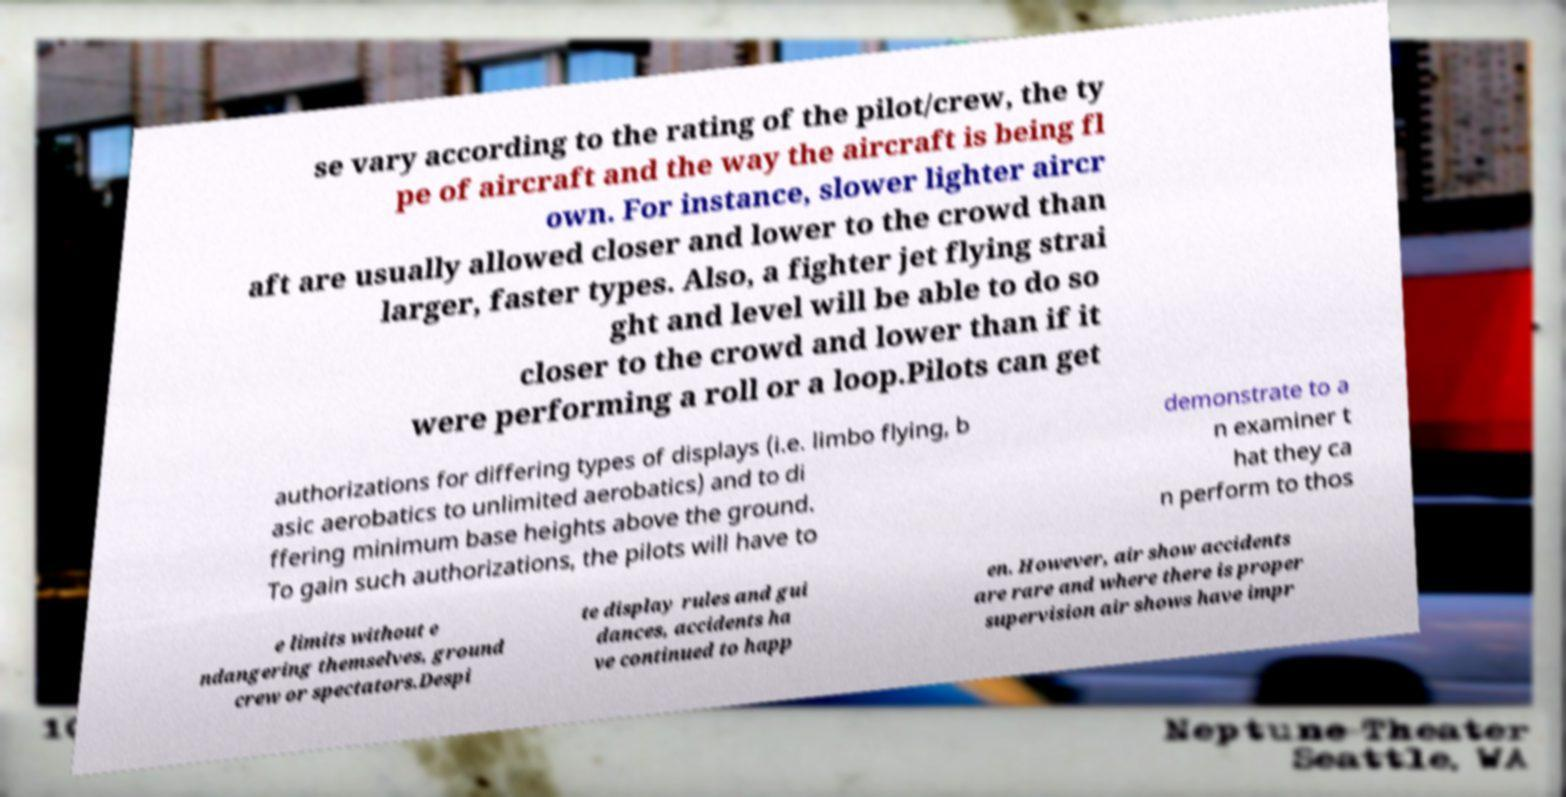Could you assist in decoding the text presented in this image and type it out clearly? se vary according to the rating of the pilot/crew, the ty pe of aircraft and the way the aircraft is being fl own. For instance, slower lighter aircr aft are usually allowed closer and lower to the crowd than larger, faster types. Also, a fighter jet flying strai ght and level will be able to do so closer to the crowd and lower than if it were performing a roll or a loop.Pilots can get authorizations for differing types of displays (i.e. limbo flying, b asic aerobatics to unlimited aerobatics) and to di ffering minimum base heights above the ground. To gain such authorizations, the pilots will have to demonstrate to a n examiner t hat they ca n perform to thos e limits without e ndangering themselves, ground crew or spectators.Despi te display rules and gui dances, accidents ha ve continued to happ en. However, air show accidents are rare and where there is proper supervision air shows have impr 